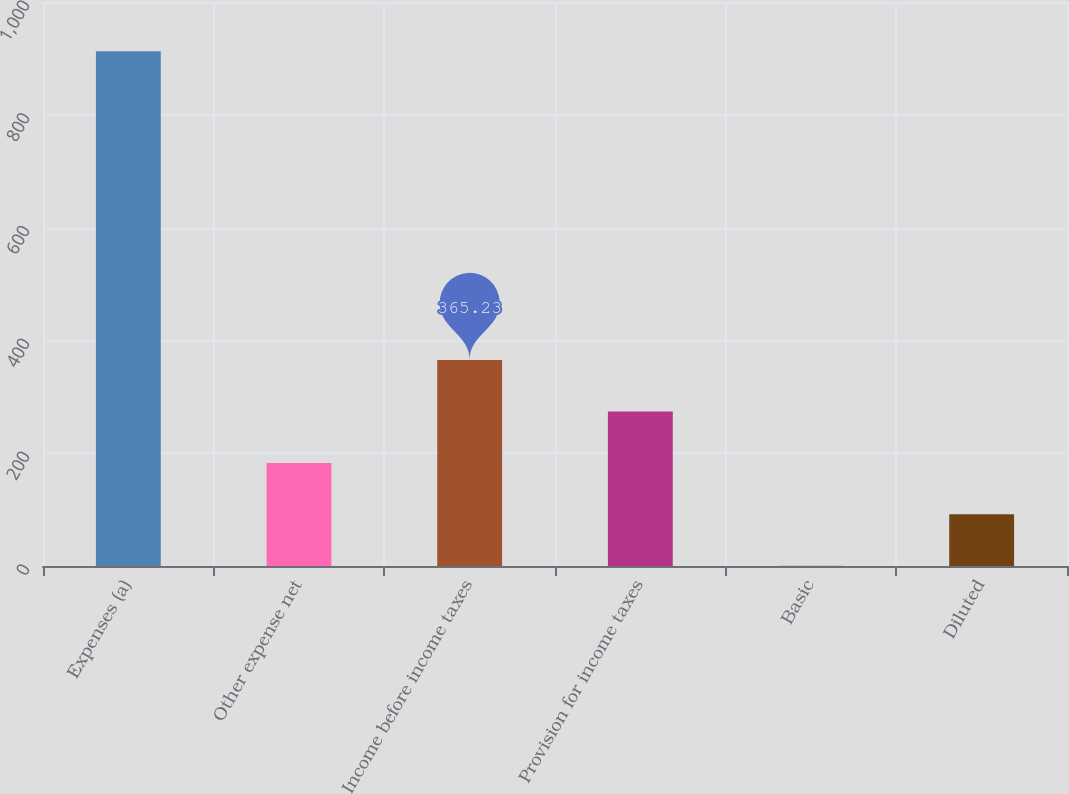<chart> <loc_0><loc_0><loc_500><loc_500><bar_chart><fcel>Expenses (a)<fcel>Other expense net<fcel>Income before income taxes<fcel>Provision for income taxes<fcel>Basic<fcel>Diluted<nl><fcel>912.6<fcel>182.77<fcel>365.23<fcel>274<fcel>0.31<fcel>91.54<nl></chart> 